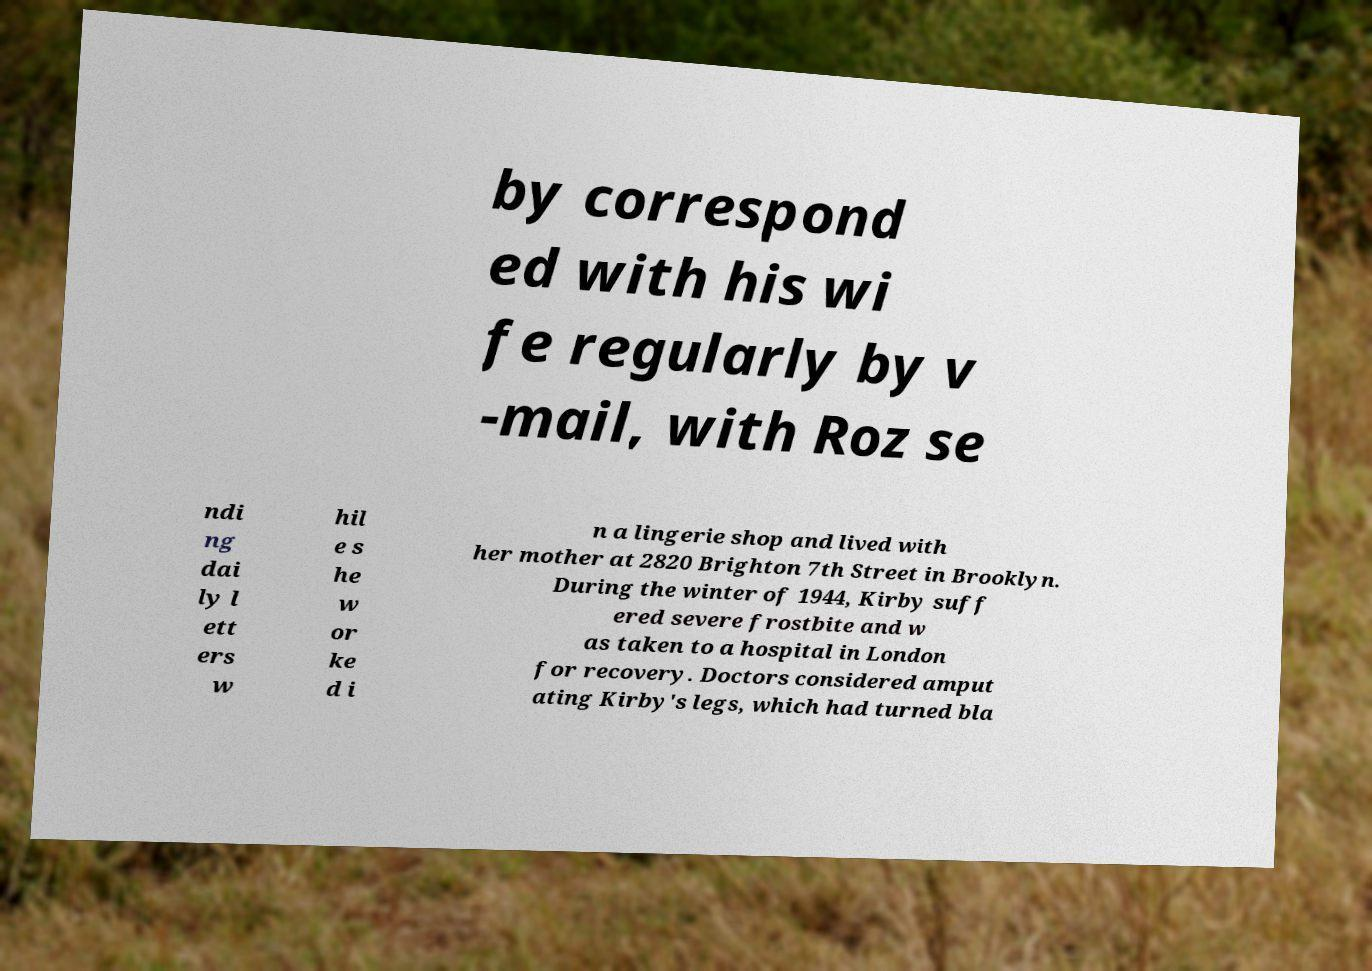What messages or text are displayed in this image? I need them in a readable, typed format. by correspond ed with his wi fe regularly by v -mail, with Roz se ndi ng dai ly l ett ers w hil e s he w or ke d i n a lingerie shop and lived with her mother at 2820 Brighton 7th Street in Brooklyn. During the winter of 1944, Kirby suff ered severe frostbite and w as taken to a hospital in London for recovery. Doctors considered amput ating Kirby's legs, which had turned bla 